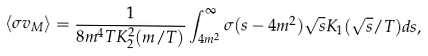<formula> <loc_0><loc_0><loc_500><loc_500>\langle \sigma v _ { M } \rangle = \frac { 1 } { 8 m ^ { 4 } T K _ { 2 } ^ { 2 } ( m / T ) } \int _ { 4 m ^ { 2 } } ^ { \infty } \sigma ( s - 4 m ^ { 2 } ) \sqrt { s } K _ { 1 } ( \sqrt { s } / T ) d s ,</formula> 